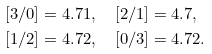<formula> <loc_0><loc_0><loc_500><loc_500>[ 3 / 0 ] & = 4 . 7 1 , \quad [ 2 / 1 ] = 4 . 7 , \\ [ 1 / 2 ] & = 4 . 7 2 , \quad [ 0 / 3 ] = 4 . 7 2 .</formula> 